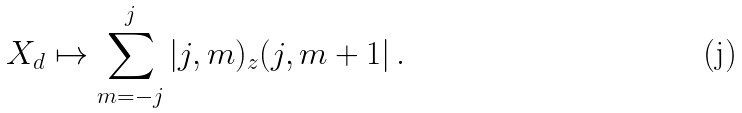Convert formula to latex. <formula><loc_0><loc_0><loc_500><loc_500>X _ { d } \mapsto \sum _ { m = - j } ^ { j } | j , m ) _ { z } ( j , m + 1 | \, .</formula> 